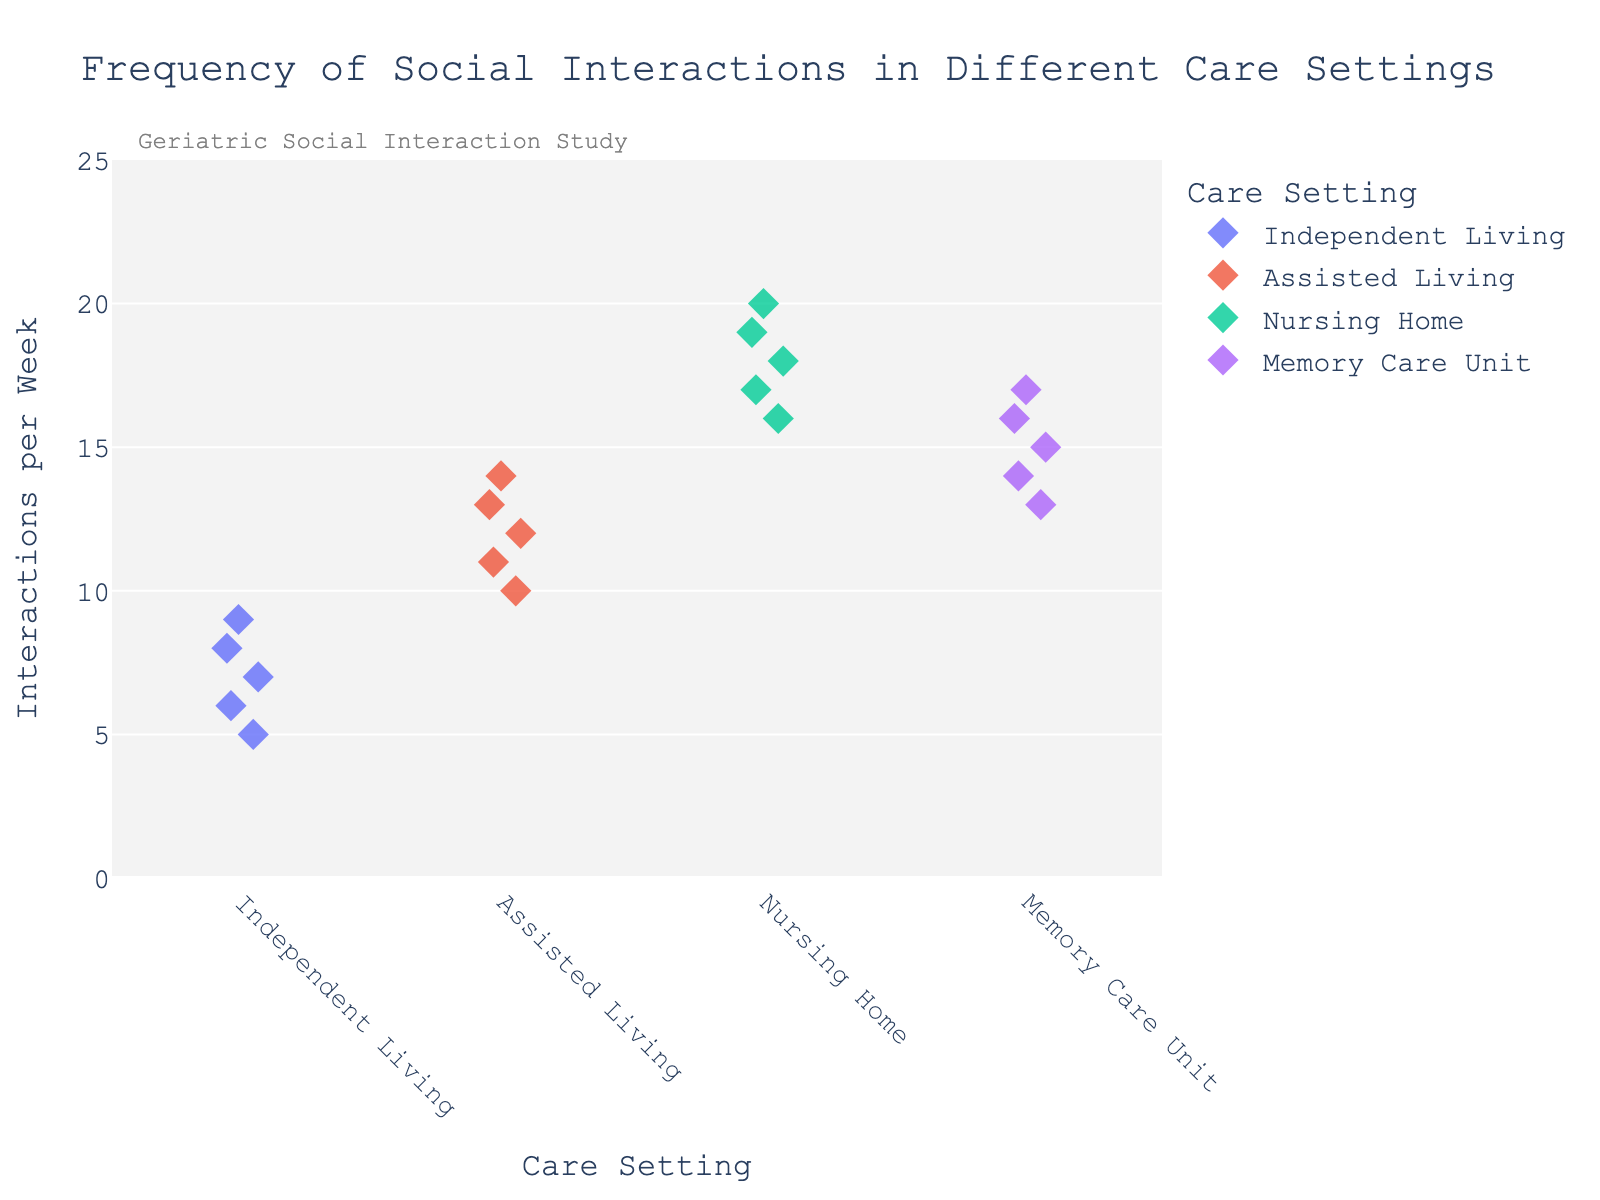What is the title of the plot? The title is displayed at the top of the plot, typically centered and often in larger fonts.
Answer: Frequency of Social Interactions in Different Care Settings How many care settings are compared in this plot? The different care settings are labeled along the x-axis.
Answer: Four Which care setting has the highest frequency of social interactions per week? By examining the y-axis values for each care setting, we look for the highest density of points near the top.
Answer: Nursing Home Which care setting shows the lowest frequency of social interactions? By examining the y-axis values for each care setting, we look for the lowest density of points near the bottom.
Answer: Independent Living What is the range of social interactions per week for residents of Assisted Living? Locate all points under "Assisted Living" and note their positions along the y-axis.
Answer: 10 to 14 On average, do residents of Memory Care Units have more or fewer social interactions compared to residents of Assisted Living? Calculate the average number of interactions by summing the interactions and dividing by the number of data points for both settings, then compare. Memory Care Unit: (15+13+17+14+16)/5 = 15; Assisted Living: (12+10+14+11+13)/5 = 12
Answer: More Which care setting has the most variance in social interactions per week? The care setting with the widest spread of points on the y-axis has the most variance.
Answer: Nursing Home How does the median number of social interactions per week for residents in Independent Living compare to those in Nursing Homes? Identify the median by locating the middle value in each set when arranged in ascending order. Independent Living: Median = (6+7+8)/3 = 7; Nursing Home: Median = (17+18)/2 = 18
Answer: Lower Describe the jitter effect in the plot. Jitter spreads out the points horizontally to prevent overlap and to show the density of points around certain values.
Answer: Prevents overlap, shows density Is there a noticeable trend in the frequency of social interactions across different care settings here? Examine if there is a pattern or progression in interaction frequencies from one care setting to another.
Answer: Yes, increases from Independent Living to Nursing Home 